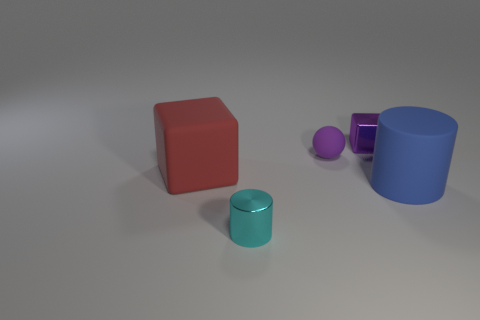Add 4 cyan cylinders. How many objects exist? 9 Subtract all cubes. How many objects are left? 3 Subtract all yellow balls. How many cyan cylinders are left? 1 Subtract all blue rubber things. Subtract all small cyan shiny cylinders. How many objects are left? 3 Add 3 large red things. How many large red things are left? 4 Add 3 red objects. How many red objects exist? 4 Subtract all blue cylinders. How many cylinders are left? 1 Subtract 0 red cylinders. How many objects are left? 5 Subtract 1 blocks. How many blocks are left? 1 Subtract all yellow cubes. Subtract all green cylinders. How many cubes are left? 2 